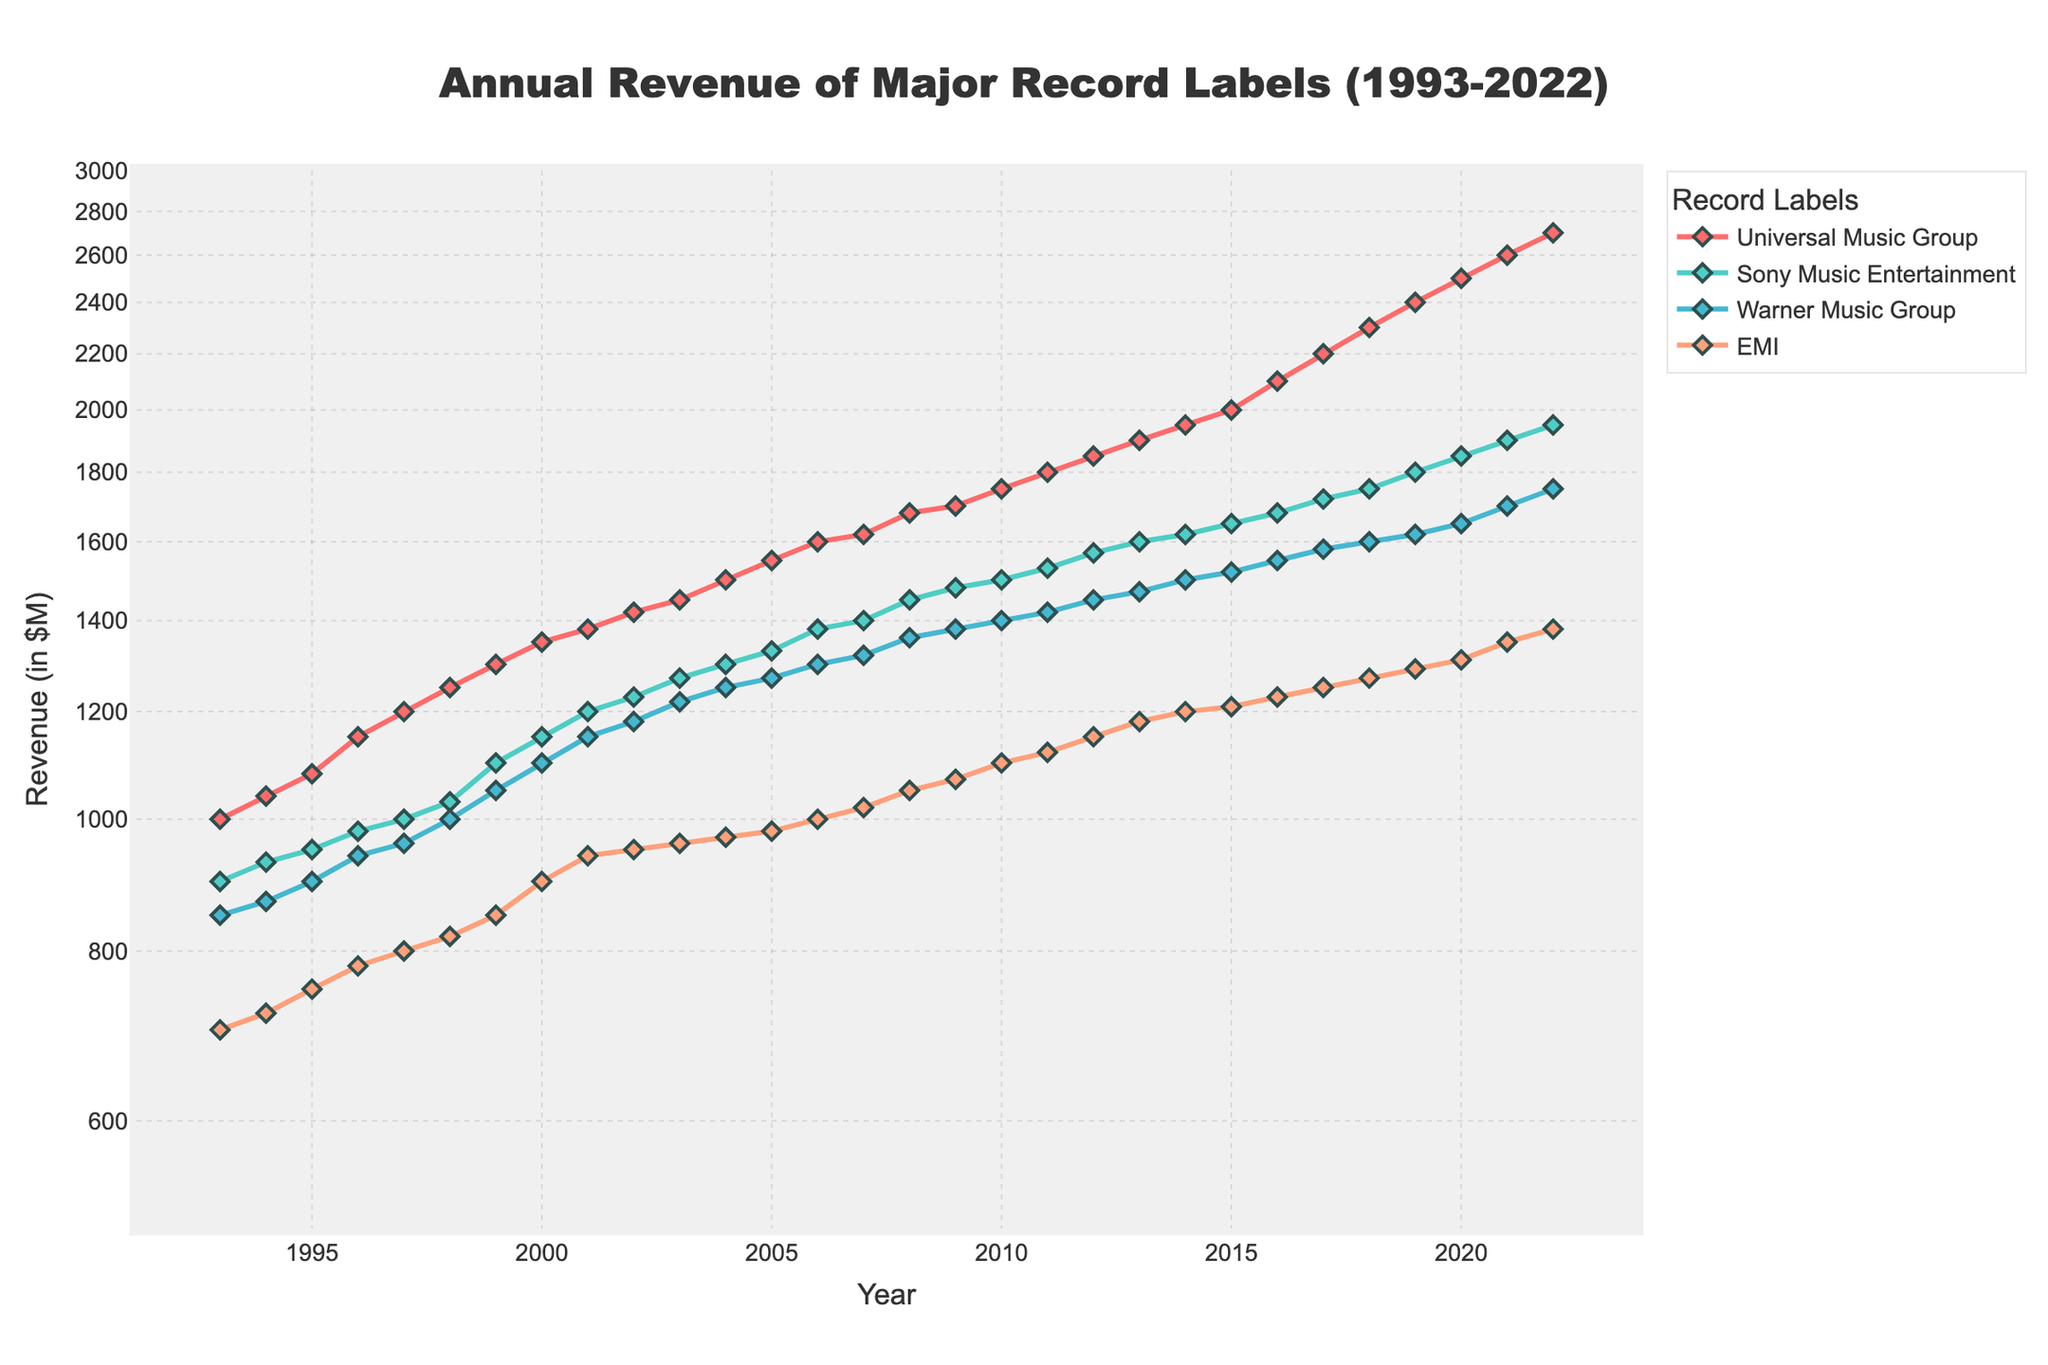What's the title of the figure? The title is prominently displayed at the top center of the figure.
Answer: Annual Revenue of Major Record Labels (1993-2022) Which record label had the highest annual revenue in 2022? Look at the data points for 2022 on the x-axis and identify the label with the highest y-axis value.
Answer: Universal Music Group How does Sony Music Entertainment's revenue trend compare to Warner Music Group from 1993 to 2022? Compare the line trends for both labels over the years. Sony Music Entertainment starts with higher revenue than Warner Music Group in 1993, and this gap is maintained over the years, with both having an overall increasing trend.
Answer: Sony Music consistently has higher revenue What is the average annual revenue of EMI from 1993 to 2022? Sum the yearly revenue values for EMI and divide by the number of years (30). Average = (700 + 720 + ... + 1380) / 30
Answer: $1007 million In which year did Universal Music Group achieve a revenue of approximately $2000 million? Find the data point where Universal Music Group touches around the $2000 million mark on the y-axis.
Answer: 2015 Which label had the smallest revenue increase between 1993 and 2022? Calculate the difference in revenue between 2022 and 1993 for each label. Compare these increases to identify the smallest one.
Answer: EMI Between which consecutive years did Warner Music Group see the largest annual increase? Calculate the annual revenue differences for Warner Music Group and find the maximum increase. The differences are (900-850), (940-900), ..., (1700-1650).
Answer: Between 2021 and 2022 By how much did EMI's revenue change from 2015 to 2022? Subtract EMI's revenue in 2015 from its revenue in 2022. (1380 - 1210)
Answer: $170 million On the log-scale y-axis, which label appears to have the steadiest growth? Steady growth on a log-scale appears as a straight line. Determine which label's line is the straightest over the period.
Answer: Sony Music Entertainment Which label had revenue closest to $1500 million in 2010? Locate the data points at the year 2010 on the x-axis and see which label's y-value is nearest to $1500 million.
Answer: Universal Music Group 